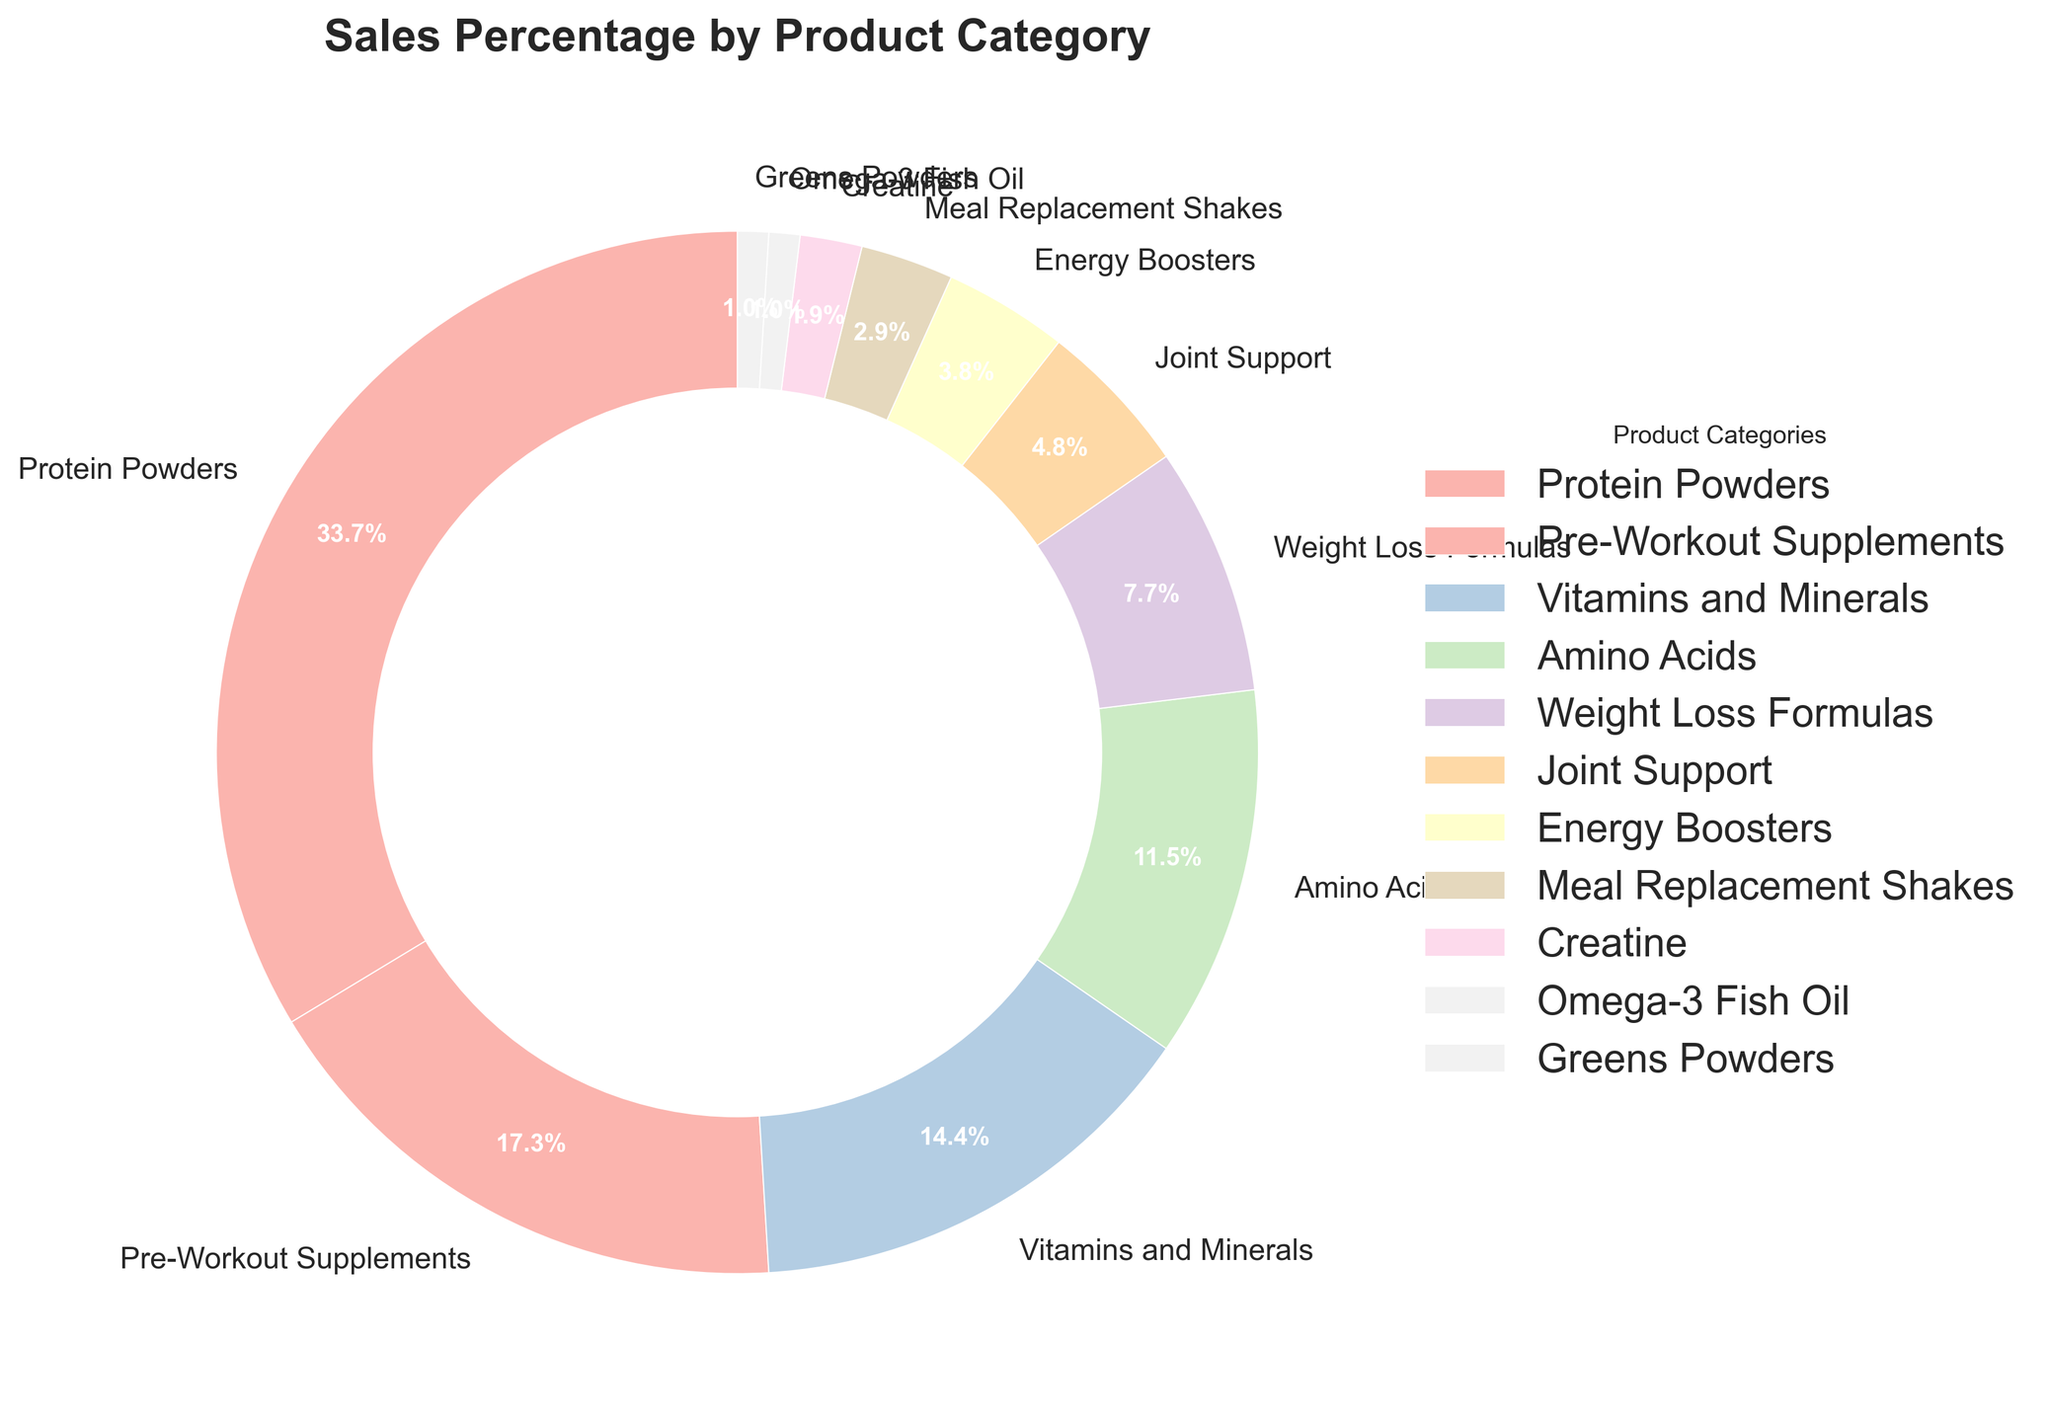Which product category has the highest percentage of sales? By observing the pie chart, it is clear that "Protein Powders" occupies the largest section of the pie chart, labeled with 35%.
Answer: Protein Powders Which product categories combined make up exactly 20% of the sales? By checking the percentages of each category, "Joint Support" (5%) and "Weight Loss Formulas" (8%) combined make 13%, and adding "Greens Powders" (1%) adds up to 14%, and adding "Creatine" (2%) and "Omega-3 Fish Oil" (1%) = 17%, but "Energy Boosters" (4%) + "Greens Powders" (1%) = 20%.
Answer: Energy Boosters and Greens Powders What is the total percentage of sales for categories related to performance enhancement (Protein Powders, Pre-Workout Supplements, and Amino Acids)? Sum the percentages of "Protein Powders" (35%), "Pre-Workout Supplements" (18%), and "Amino Acids" (12%): 35 + 18 + 12 = 65%
Answer: 65% Compare the sales percentages of "Pre-Workout Supplements" and "Amino Acids". Which one is higher and by how much? "Pre-Workout Supplements" has 18%, while "Amino Acids" has 12%. The difference is 18 - 12 = 6%.
Answer: Pre-Workout Supplements are higher by 6% Are there more sales from "Joint Support" or "Energy Boosters"? The chart segment for "Joint Support" is larger and labeled with 5%, while "Energy Boosters" is 4%. Therefore, "Joint Support" has more sales.
Answer: Joint Support Which categories collectively make up just over half of the sales? Sum the percentages starting from the highest until it surpasses 50%. "Protein Powders" (35%) + "Pre-Workout Supplements" (18%) = 53%.
Answer: Protein Powders and Pre-Workout Supplements Is the combined sales percentage of "Meal Replacement Shakes" and "Creatine" less than "Vitamins and Minerals"? Sum the values: "Meal Replacement Shakes" (3%) + "Creatine" (2%) = 5%, while "Vitamins and Minerals" alone have 15%. 5% is less than 15%.
Answer: Yes What is the combined sales percentage of the least contributing categories (Omega-3 Fish Oil and Greens Powders)? The two smallest segments are "Omega-3 Fish Oil" (1%) and "Greens Powders" (1%). Their combined percentage is 1% + 1% = 2%.
Answer: 2% Which segment represents "Vitamins and Minerals" by its color in the pie chart? Identify the color associated with "Vitamins and Minerals" in the legend and match it to its segment in the pie chart.
Answer: Light green or the third segmented section starting from the top If "Protein Powders" and "Vitamins and Minerals" percentages were swapped, what would be the new percentage for "Protein Powders"? If swapped, "Protein Powders" would have the percentage of "Vitamins and Minerals", which is 15%.
Answer: 15% 